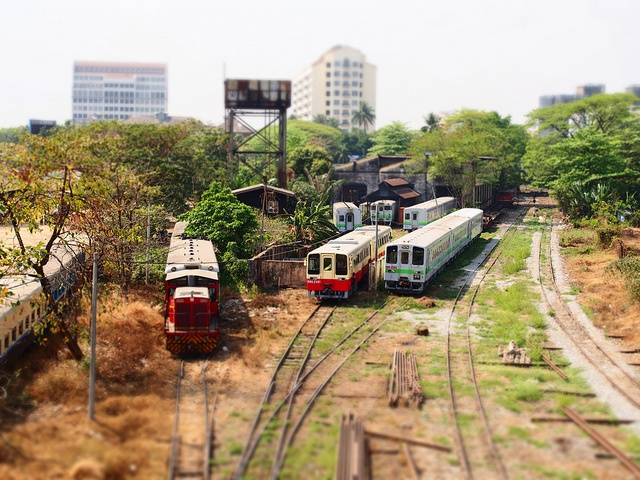Describe the objects in this image and their specific colors. I can see train in white, black, maroon, ivory, and tan tones, train in white, black, darkgray, and gray tones, train in white, tan, black, gray, and beige tones, train in white, black, ivory, brown, and tan tones, and train in white, darkgray, lightgray, gray, and black tones in this image. 